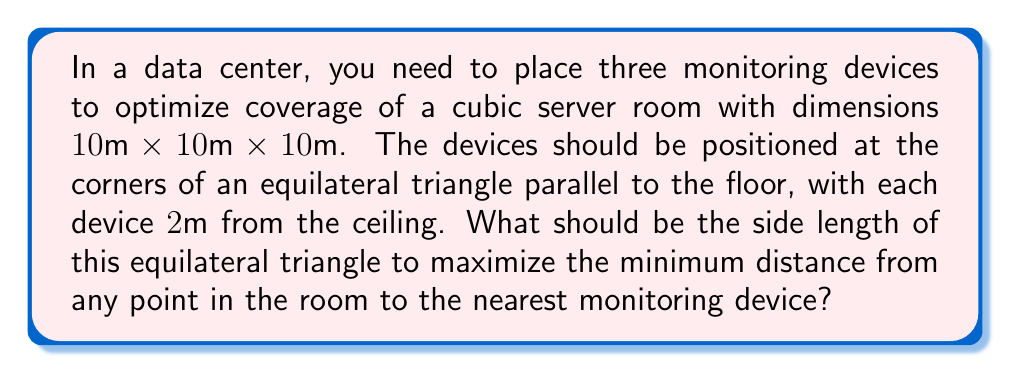Could you help me with this problem? Let's approach this step-by-step:

1) First, we need to understand the geometry of the problem. We have a cube of side length 10m, and we're placing three devices in an equilateral triangle 2m from the ceiling.

2) The worst-case scenario (maximum distance to nearest device) will occur at a point on the floor that is equidistant from all three devices.

3) Let's denote the side length of the equilateral triangle as $s$. The height of this triangle from its center to any vertex is:

   $$h = \frac{\sqrt{3}}{2}s$$

4) Now, imagine a line from the center of the triangle to the floor. This line forms a right angle with the floor and has a length of 8m (since the devices are 2m from the ceiling in a 10m high room).

5) The distance $d$ from any point on the floor to a device is given by the Pythagorean theorem:

   $$d^2 = r^2 + 8^2$$

   where $r$ is the distance from the point on the floor to the center of the triangle.

6) The maximum value of $r$ occurs at the center of the triangle and is equal to $\frac{\sqrt{3}}{3}s$.

7) Therefore, the maximum distance to any device is:

   $$d_{max} = \sqrt{(\frac{\sqrt{3}}{3}s)^2 + 8^2}$$

8) To minimize this maximum distance, we differentiate with respect to $s$ and set to zero:

   $$\frac{d}{ds}d_{max} = \frac{1}{2}\left((\frac{\sqrt{3}}{3}s)^2 + 8^2\right)^{-1/2} \cdot \frac{2\sqrt{3}}{3}s \cdot \frac{\sqrt{3}}{3} = 0$$

9) Solving this equation:

   $$\frac{s}{\sqrt{s^2 + 192}} = 0$$

   $$s^2 = 192$$
   $$s = 4\sqrt{3} \approx 6.93$$

10) This is indeed a minimum, as the second derivative is positive at this point.

Therefore, the optimal side length of the equilateral triangle is $4\sqrt{3}$ meters.
Answer: The optimal side length of the equilateral triangle formed by the three monitoring devices is $4\sqrt{3}$ meters, or approximately 6.93 meters. 